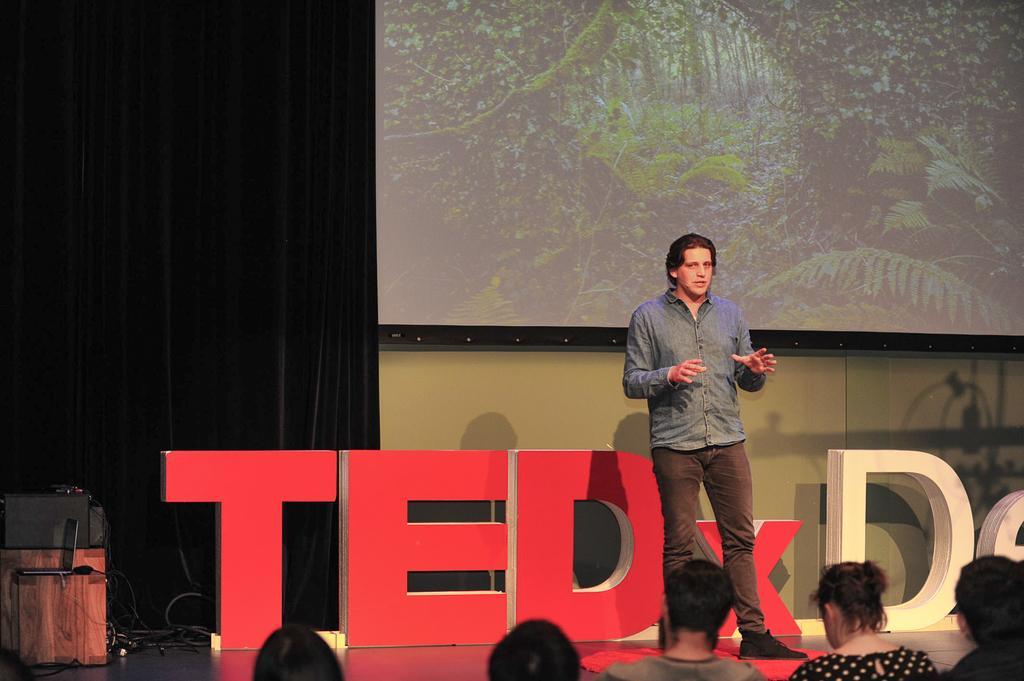Could you give a brief overview of what you see in this image? In this picture we can see a group of people and a person is standing on the stage. On the left side of the man there are boards, cables, laptop and some objects. Behind the man there is the projector screen, wall and curtains. 